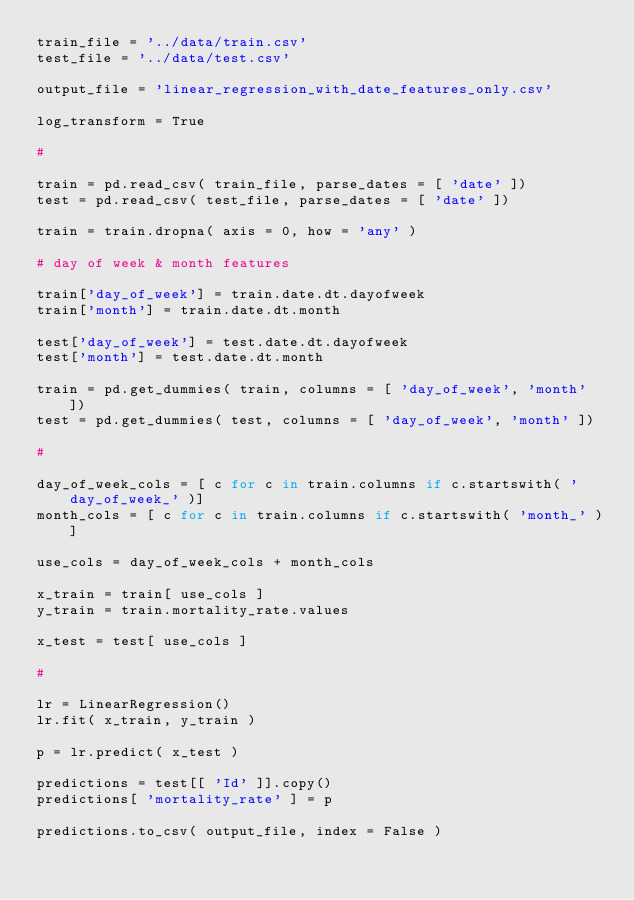Convert code to text. <code><loc_0><loc_0><loc_500><loc_500><_Python_>train_file = '../data/train.csv'
test_file = '../data/test.csv'

output_file = 'linear_regression_with_date_features_only.csv'

log_transform = True

#

train = pd.read_csv( train_file, parse_dates = [ 'date' ])
test = pd.read_csv( test_file, parse_dates = [ 'date' ])

train = train.dropna( axis = 0, how = 'any' )

# day of week & month features

train['day_of_week'] = train.date.dt.dayofweek
train['month'] = train.date.dt.month

test['day_of_week'] = test.date.dt.dayofweek
test['month'] = test.date.dt.month

train = pd.get_dummies( train, columns = [ 'day_of_week', 'month' ])
test = pd.get_dummies( test, columns = [ 'day_of_week', 'month' ])

#

day_of_week_cols = [ c for c in train.columns if c.startswith( 'day_of_week_' )]
month_cols = [ c for c in train.columns if c.startswith( 'month_' )]

use_cols = day_of_week_cols + month_cols

x_train = train[ use_cols ]
y_train = train.mortality_rate.values

x_test = test[ use_cols ]

#

lr = LinearRegression()
lr.fit( x_train, y_train )

p = lr.predict( x_test )

predictions = test[[ 'Id' ]].copy()
predictions[ 'mortality_rate' ] = p

predictions.to_csv( output_file, index = False )
</code> 